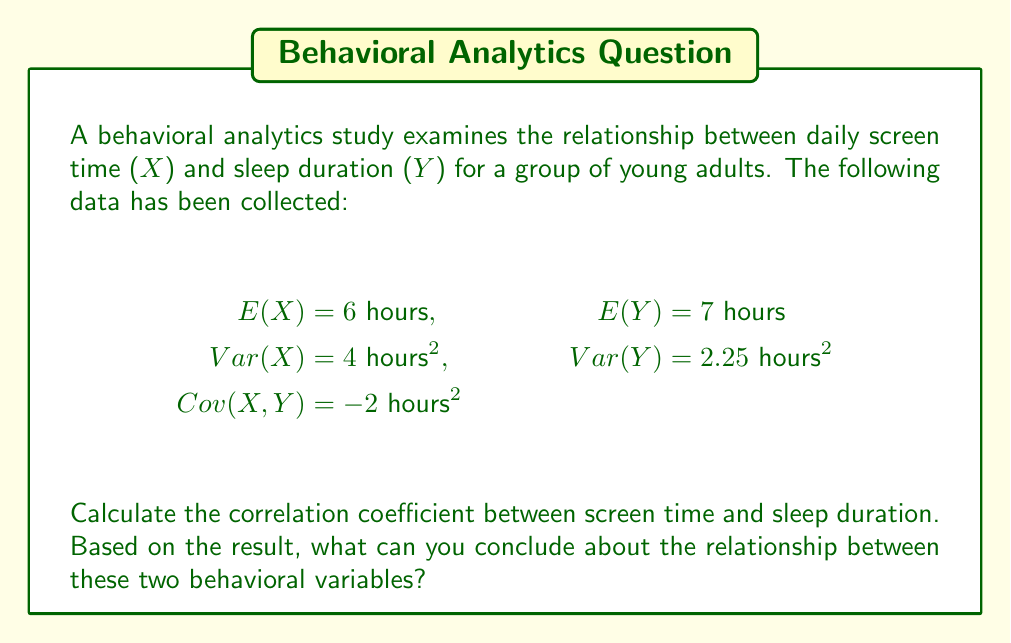What is the answer to this math problem? To calculate the correlation coefficient between screen time (X) and sleep duration (Y), we'll use the formula:

$$\rho_{X,Y} = \frac{Cov(X,Y)}{\sqrt{Var(X) \cdot Var(Y)}}$$

Where:
$\rho_{X,Y}$ is the correlation coefficient
$Cov(X,Y)$ is the covariance between X and Y
$Var(X)$ is the variance of X
$Var(Y)$ is the variance of Y

Step 1: Insert the given values into the formula:
$$\rho_{X,Y} = \frac{-2}{\sqrt{4 \cdot 2.25}}$$

Step 2: Calculate the denominator:
$$\sqrt{4 \cdot 2.25} = \sqrt{9} = 3$$

Step 3: Complete the calculation:
$$\rho_{X,Y} = \frac{-2}{3} \approx -0.667$$

Interpretation:
The correlation coefficient ranges from -1 to 1, where:
- A value of -1 indicates a perfect negative linear relationship
- A value of 0 indicates no linear relationship
- A value of 1 indicates a perfect positive linear relationship

The calculated correlation coefficient of approximately -0.667 suggests a moderate to strong negative linear relationship between screen time and sleep duration. This means that as screen time increases, sleep duration tends to decrease, and vice versa.

In the context of behavioral analytics, this result indicates that there is a significant inverse relationship between these two variables. This information could be valuable for developing interventions or recommendations to improve sleep habits among young adults.
Answer: $\rho_{X,Y} \approx -0.667$; moderate to strong negative correlation 